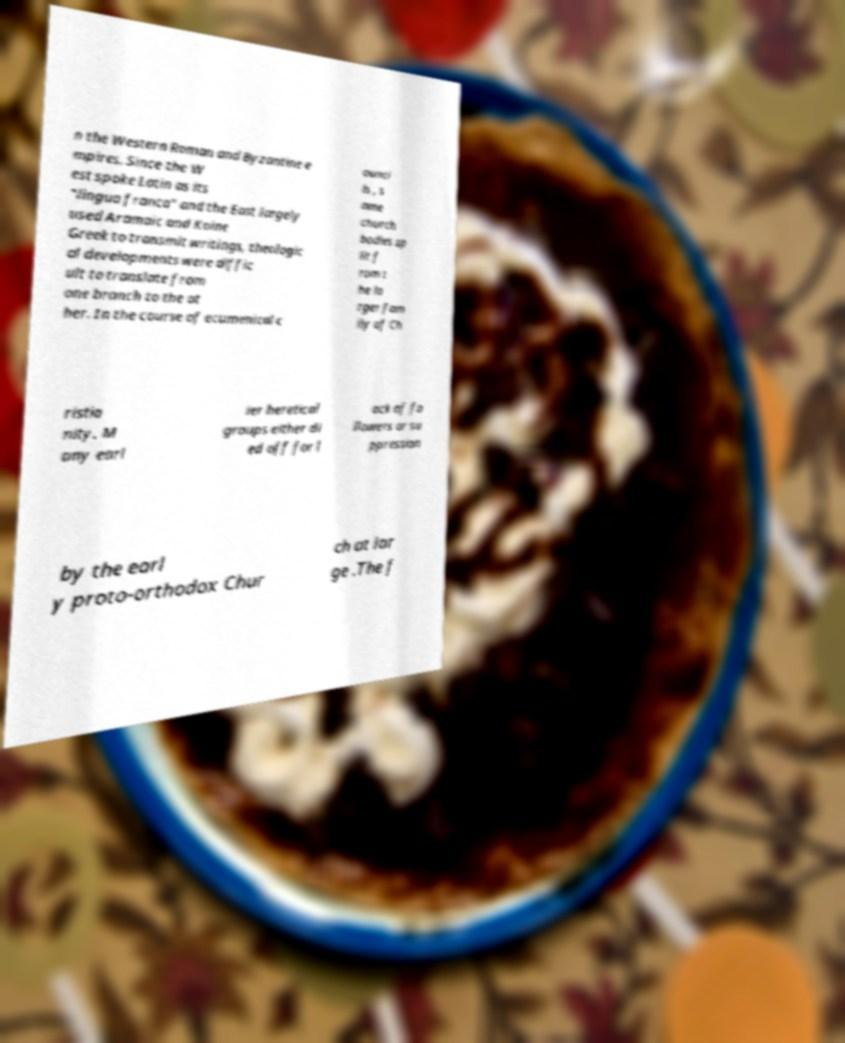Can you read and provide the text displayed in the image?This photo seems to have some interesting text. Can you extract and type it out for me? n the Western Roman and Byzantine e mpires. Since the W est spoke Latin as its "lingua franca" and the East largely used Aramaic and Koine Greek to transmit writings, theologic al developments were diffic ult to translate from one branch to the ot her. In the course of ecumenical c ounci ls , s ome church bodies sp lit f rom t he la rger fam ily of Ch ristia nity. M any earl ier heretical groups either di ed off for l ack of fo llowers or su ppression by the earl y proto-orthodox Chur ch at lar ge .The f 